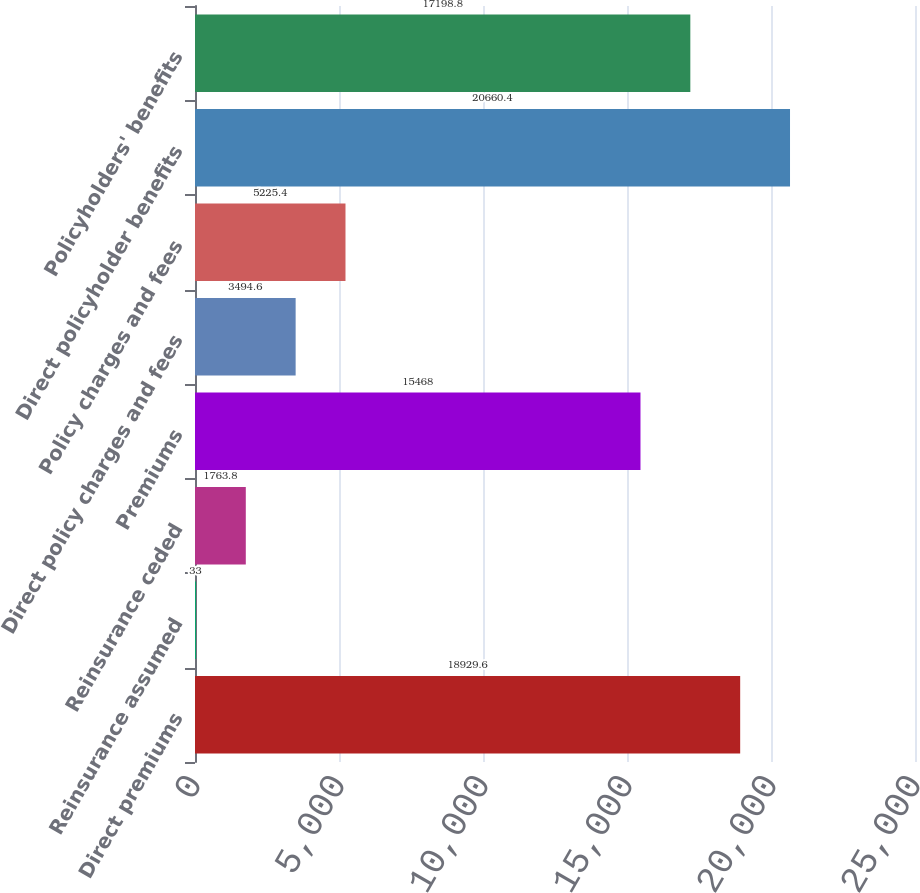Convert chart to OTSL. <chart><loc_0><loc_0><loc_500><loc_500><bar_chart><fcel>Direct premiums<fcel>Reinsurance assumed<fcel>Reinsurance ceded<fcel>Premiums<fcel>Direct policy charges and fees<fcel>Policy charges and fees<fcel>Direct policyholder benefits<fcel>Policyholders' benefits<nl><fcel>18929.6<fcel>33<fcel>1763.8<fcel>15468<fcel>3494.6<fcel>5225.4<fcel>20660.4<fcel>17198.8<nl></chart> 